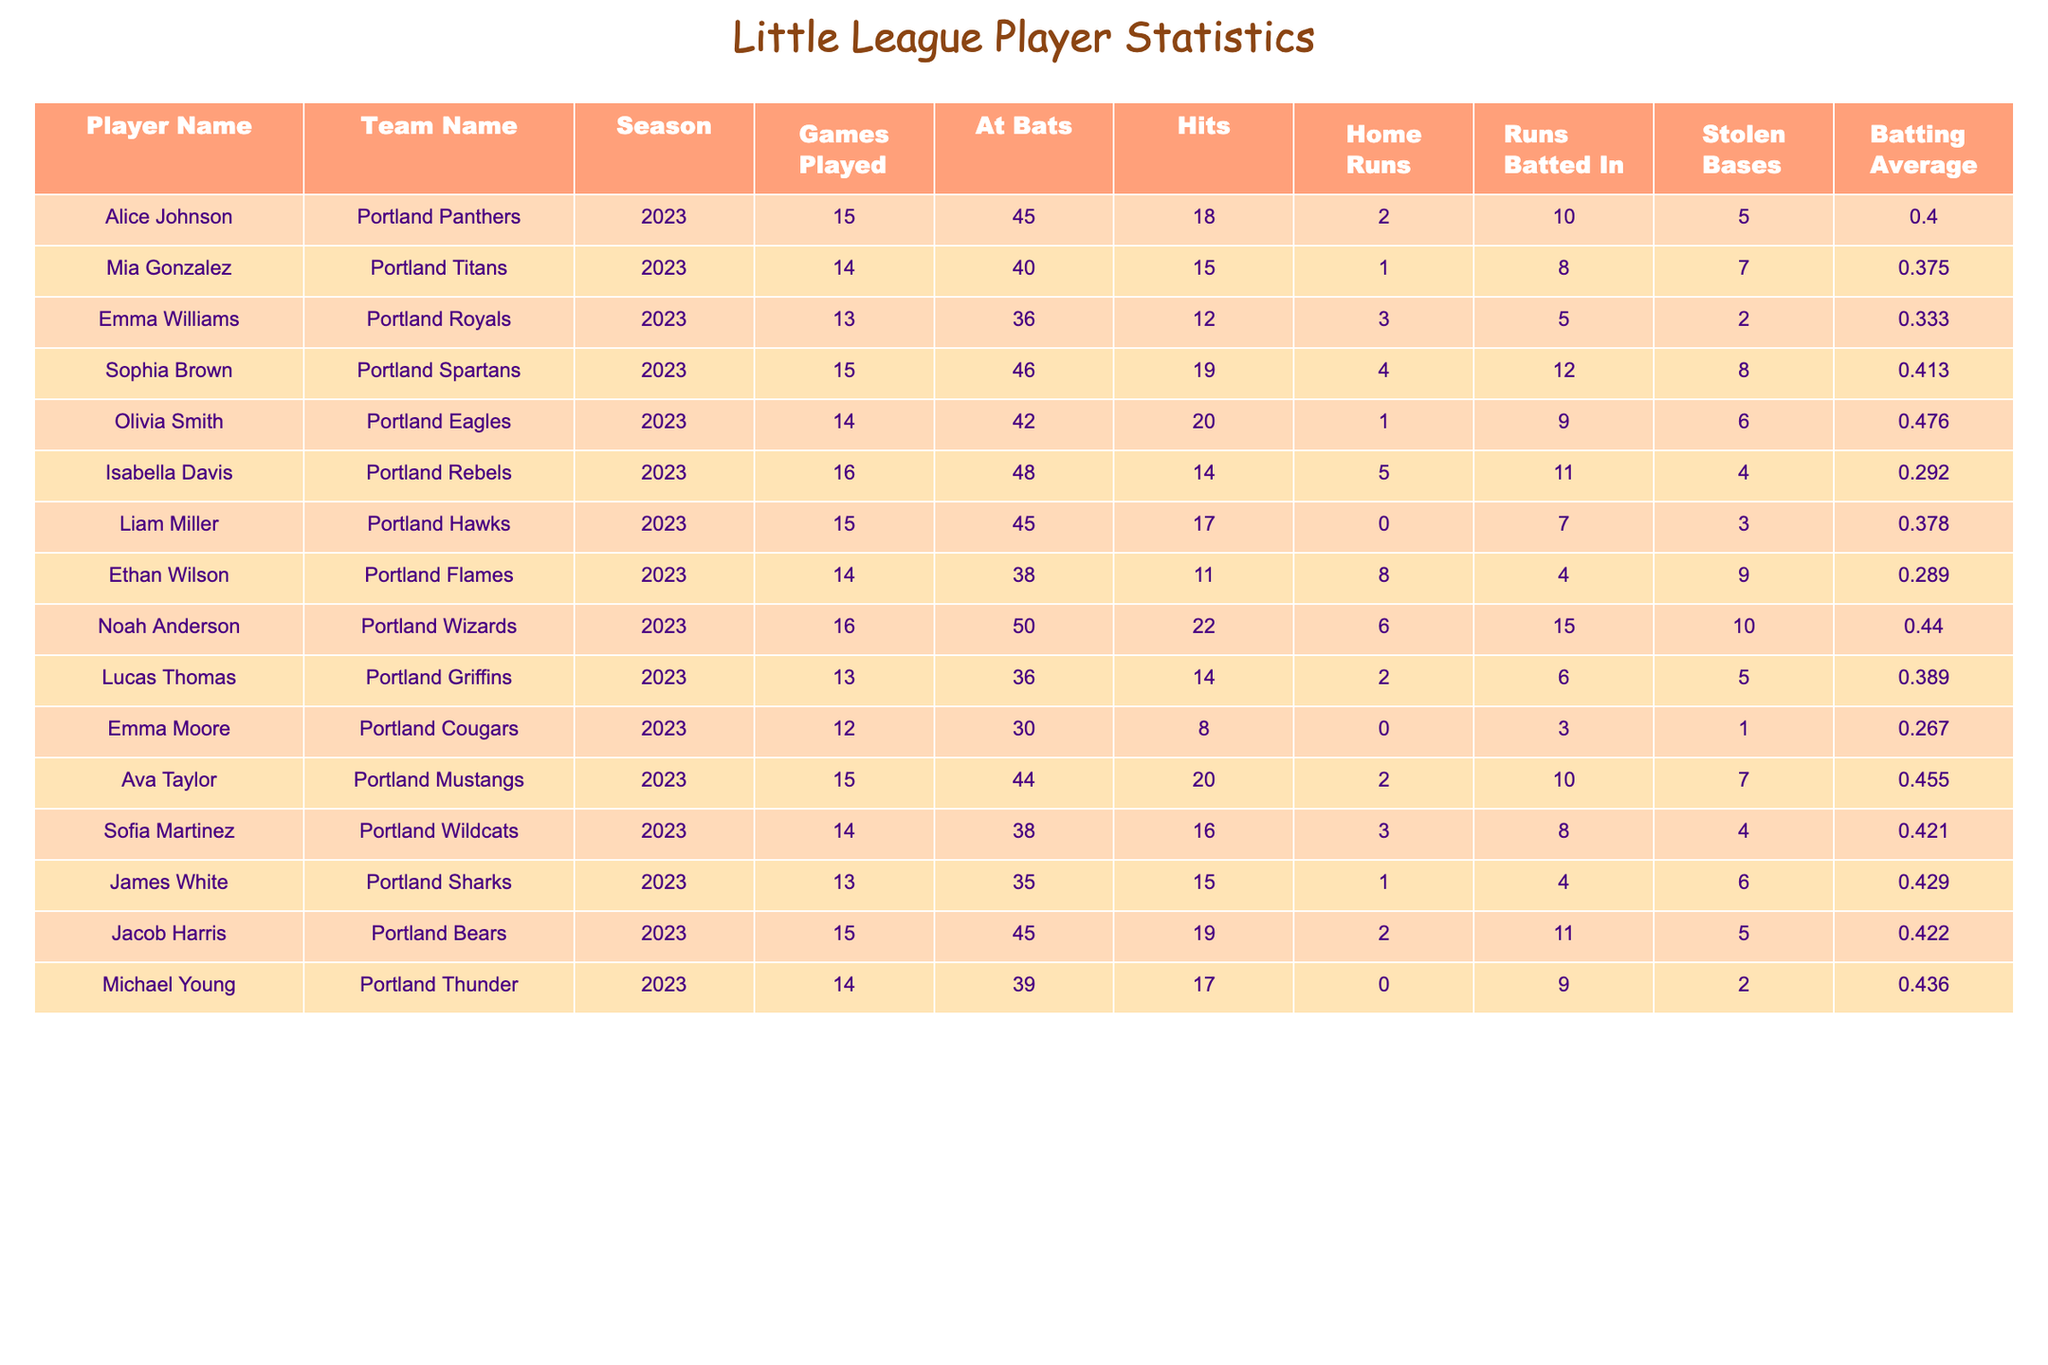What is the batting average of Olivia Smith? The table shows that Olivia Smith has a batting average listed as 0.476.
Answer: 0.476 Who hit the most home runs in the 2023 season? By looking at the 'Home Runs' column, we see that Noah Anderson, with 6 home runs, has the highest number compared to other players.
Answer: 6 How many stolen bases did Mia Gonzalez achieve? Referring to the table, Mia Gonzalez has 7 stolen bases listed in her statistics.
Answer: 7 Which player had the highest batting average and what was it? By comparing the batting averages, Sophia Brown has the highest at 0.413.
Answer: 0.413 What is the total number of stolen bases for all players listed in the table? We sum the stolen bases from each player's entry: 5 + 7 + 2 + 8 + 6 + 4 + 3 + 9 + 10 + 7 + 4 + 6 + 2 = 66.
Answer: 66 Is Emma Moore the player with the least number of hits? Checking the 'Hits' column, Emma Moore has only 8 hits, which is fewer than the hits of other players listed.
Answer: Yes Which team had the player with the highest number of runs batted in? By examining the 'Runs Batted In' column, Noah Anderson from the Portland Wizards achieved 15 runs batted in, which is the highest number compared to others.
Answer: Portland Wizards What is the average batting average of players from the Portland Titans and the Portland Eagles? The batting averages for Mia Gonzalez and Olivia Smith are 0.375 and 0.476, respectively. To find the average, we calculate (0.375 + 0.476) / 2 = 0.4255.
Answer: 0.4255 Who had the least amount of games played, and how many did they play? Looking through the 'Games Played' column, we see that Emma Moore played 12 games, which is the fewest compared to other players.
Answer: 12 